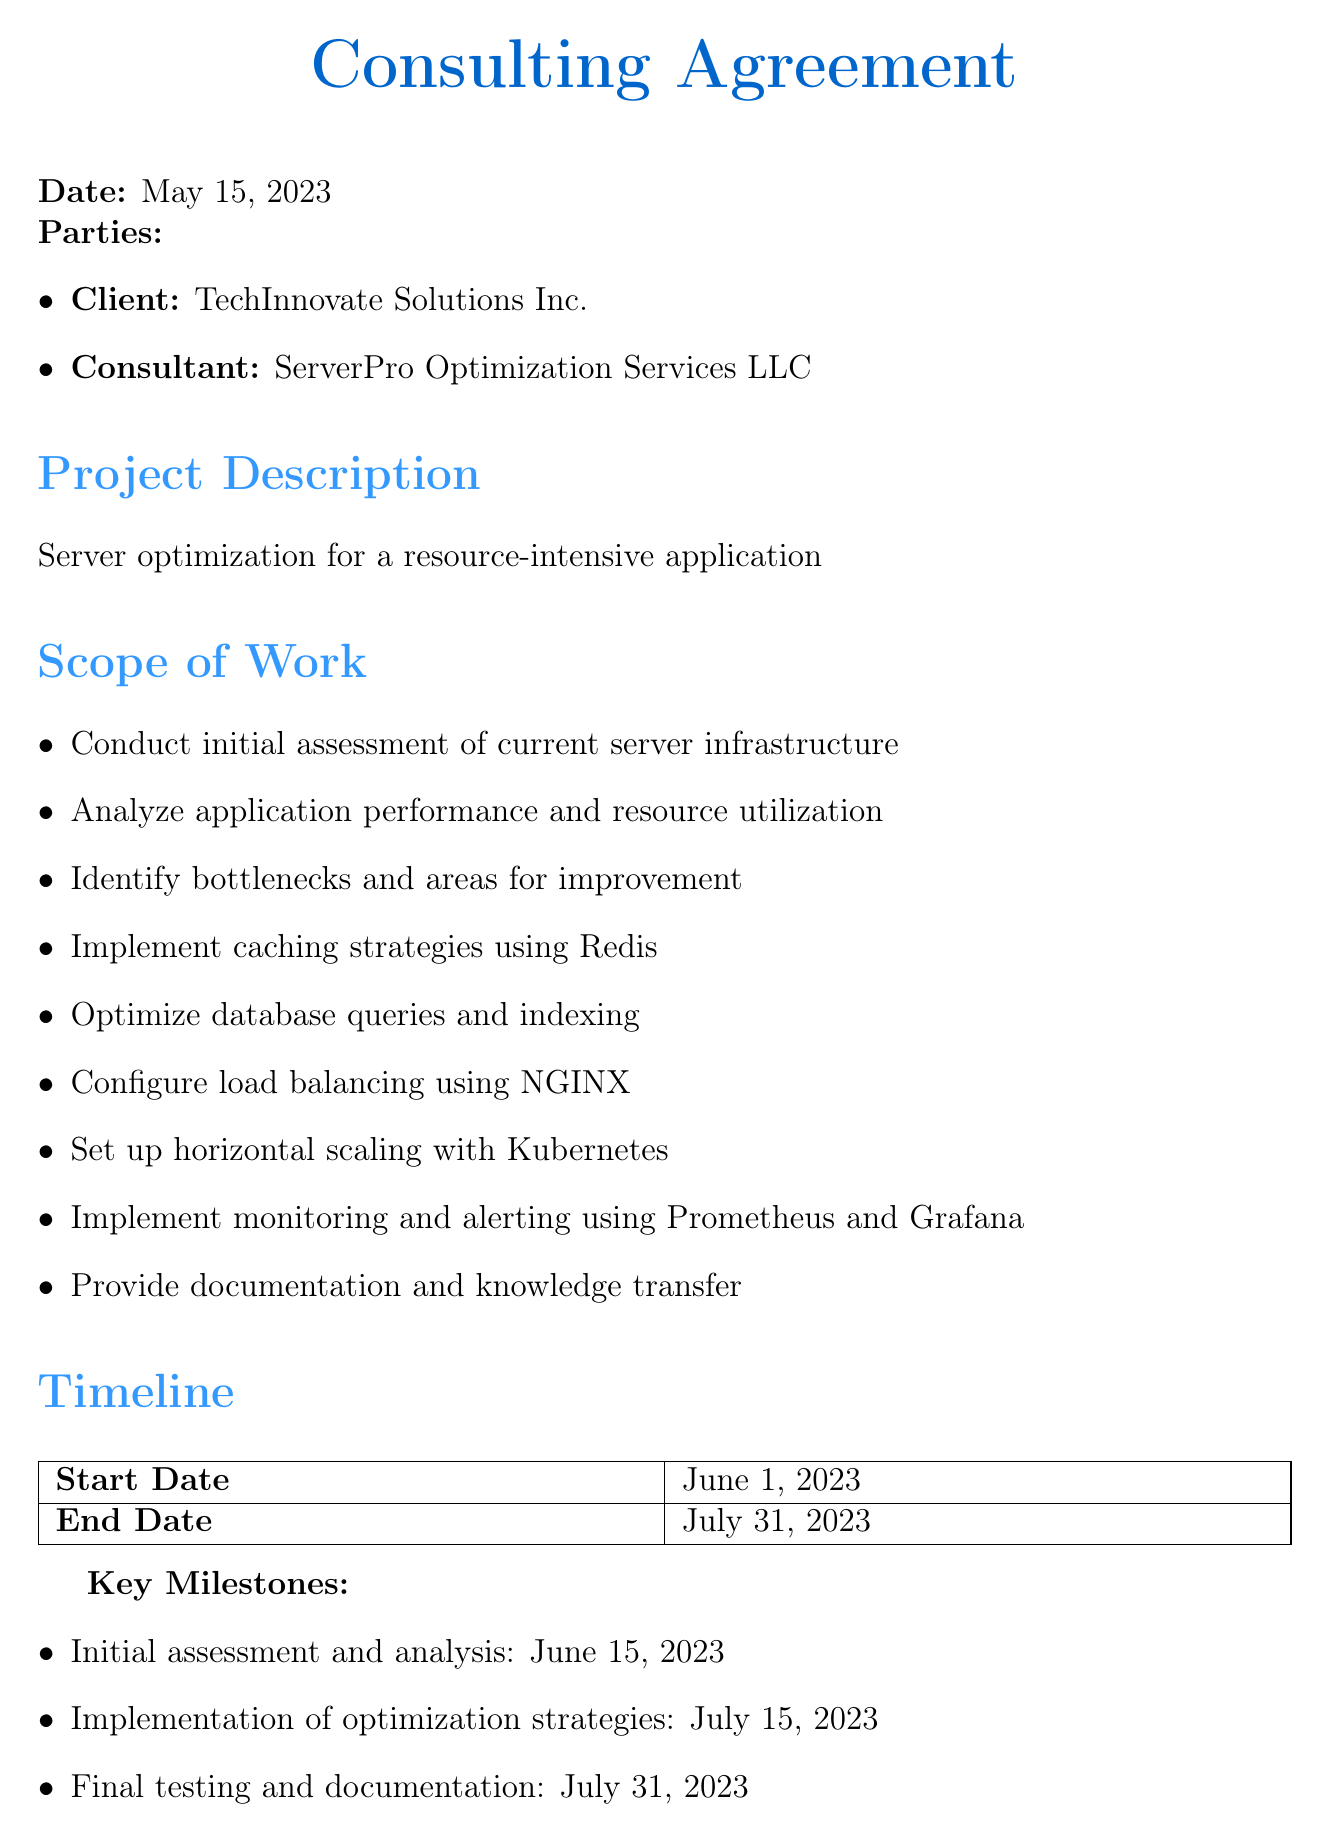What is the total fee for the consulting agreement? The total fee is stated in the payment terms section of the document.
Answer: $25,000 USD What is the start date of the project? The start date is mentioned in the timeline section of the document.
Answer: June 1, 2023 Who is the client in this agreement? The client's name is listed at the beginning of the document under the parties section.
Answer: TechInnovate Solutions Inc What is the due date for the mid-project payment? The mid-project payment due date is found in the payment schedule of the document.
Answer: July 15, 2023 How long is the confidentiality clause effective? The duration is specified in the confidentiality clause of the document.
Answer: 2 years What is one of the key milestones for this project? The key milestones are listed in the timeline section of the document.
Answer: Initial assessment and analysis Who owns the intellectual property created during the project? The ownership of intellectual property is clarified in the intellectual property section of the document.
Answer: TechInnovate Solutions Inc What is the early termination fee percentage? The percentage for the early termination fee is specified in the termination clause of the document.
Answer: 25% 